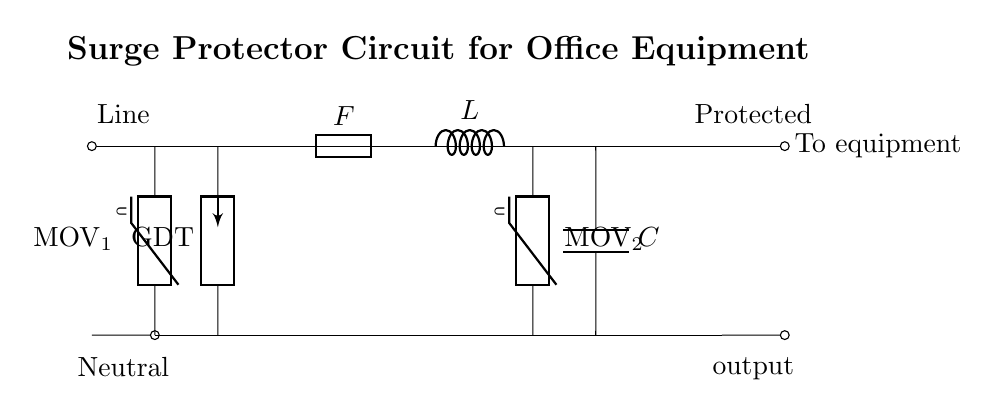What is the role of the MOV component? The MOV, or Metal-Oxide Varistor, protects equipment by clamping voltage spikes and absorbing surges. In this circuit, it's positioned to shield the system from overvoltage conditions.
Answer: Clamping voltage spikes What type of fuse is used in this circuit? The circuit diagram indicates a standard fuse labeled "F." A fuse serves as a safety device, breaking the circuit when excessive current flows.
Answer: Standard fuse What does the inductor labeled "L" do? The inductor stores energy in a magnetic field when current passes through it. In surge protector circuits, it also helps to limit the rate of current change in the event of a surge.
Answer: Stores energy How many MOVs are in the circuit? There are two Metal-Oxide Varistors (MOVs) indicated in the circuit diagram, one at the input side and one at the output side, designed for surge protection on both ends.
Answer: Two What does the GDT stand for? GDT stands for Gas Discharge Tube, a protective device that allows current to flow during surges to protect downstream equipment. In the circuit, it's placed between the MOVs to absorb excess energy.
Answer: Gas Discharge Tube Which component is responsible for energy storage? The capacitor labeled "C" is responsible for energy storage, smoothing rapid changes in voltage levels and helping maintain a stable output.
Answer: Capacitor What does the label "Protected output" indicate? "Protected output" indicates that the circuit is designed to deliver power to connected equipment while ensuring that those devices are safeguarded against voltage spikes and surges.
Answer: Safeguarded against surges 